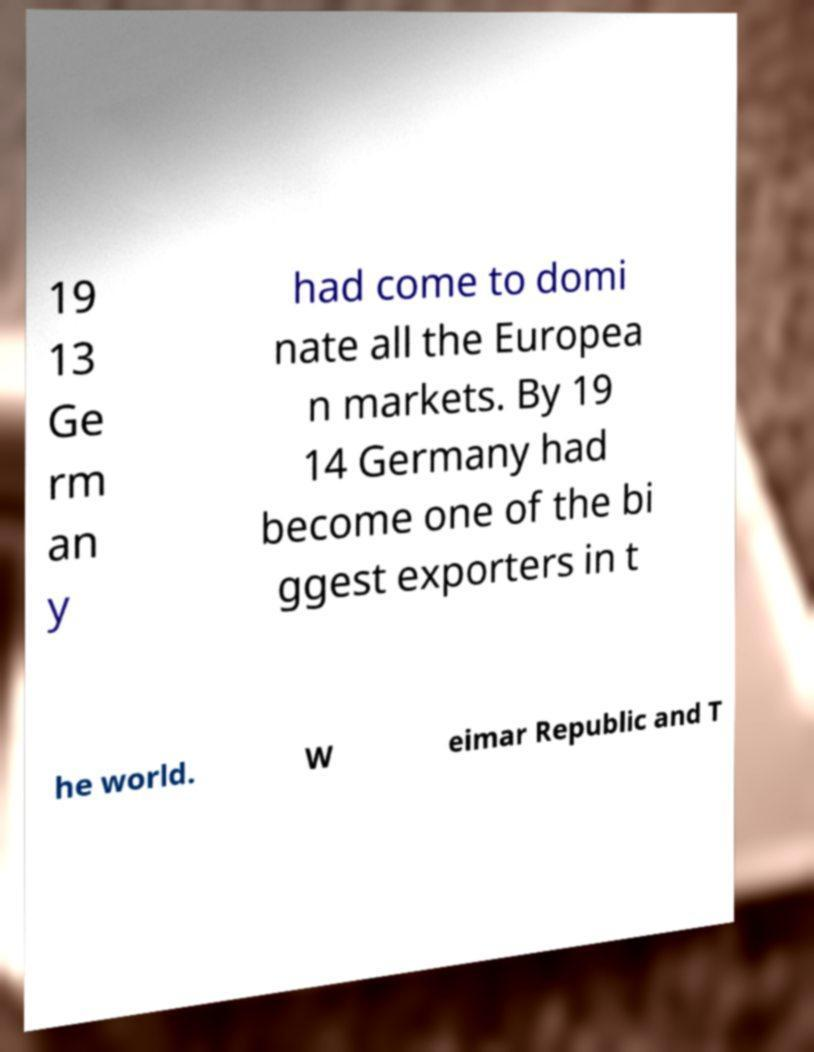There's text embedded in this image that I need extracted. Can you transcribe it verbatim? 19 13 Ge rm an y had come to domi nate all the Europea n markets. By 19 14 Germany had become one of the bi ggest exporters in t he world. W eimar Republic and T 